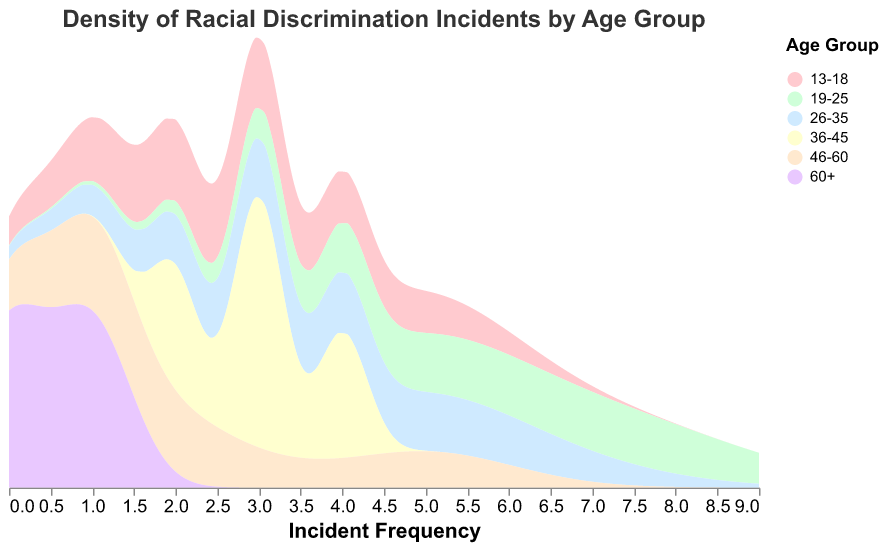What is the title of the figure? The title is located at the top of the figure and is typically the first piece of text that summarizes the content of the chart.
Answer: Density of Racial Discrimination Incidents by Age Group Which age group uses the color shade of blue in the figure? The color corresponding to each age group can be identified in the legend, where blue represents a specific group.
Answer: 60+ How many age groups are represented in the figure? The number of distinct colors or categories in the legend indicates the number of age groups.
Answer: Six What is the range of incident frequencies on the x-axis? The x-axis is labeled as "Incident Frequency" and typically includes a scale that shows the minimum and maximum values for incident frequencies.
Answer: 0 to 9 Which age group appears to have experienced the highest density of incidents? The age group with the highest peak on the density curve represents the group with the highest density of incidents.
Answer: 19-25 Which age groups have density peaks at an incident frequency of 5? By analyzing where the density curves have peaks at the incident frequency value of 5, we can identify the respective age groups.
Answer: 13-18, 19-25, 26-35, 46-60 What is the approximate density value for the age group 60+ at an incident frequency of 1? Locate the density curve for the age group 60+ and find the y-axis value corresponding to an incident frequency of 1.
Answer: Approximately 0.4 Among the age groups of 36-45 and 46-60, which one experiences a higher density at an incident frequency of 2? Compare the density curves of both age groups at the incident frequency value of 2 to see which has a higher y-value.
Answer: 46-60 What's the average incident frequency for the age group 26-35? The incident frequencies for the age group 26-35 are (6, 5, 3, 2). Sum these values and divide by the number of incidents: (6 + 5 + 3 + 2) / 4 = 16 / 4 = 4.
Answer: 4 Which age group shows the widest spread in the density plot? The width of the density curve for each age group indicates the spread. The group with the broadest curve from the leftmost to the rightmost part of the x-axis has the widest spread.
Answer: 19-25 